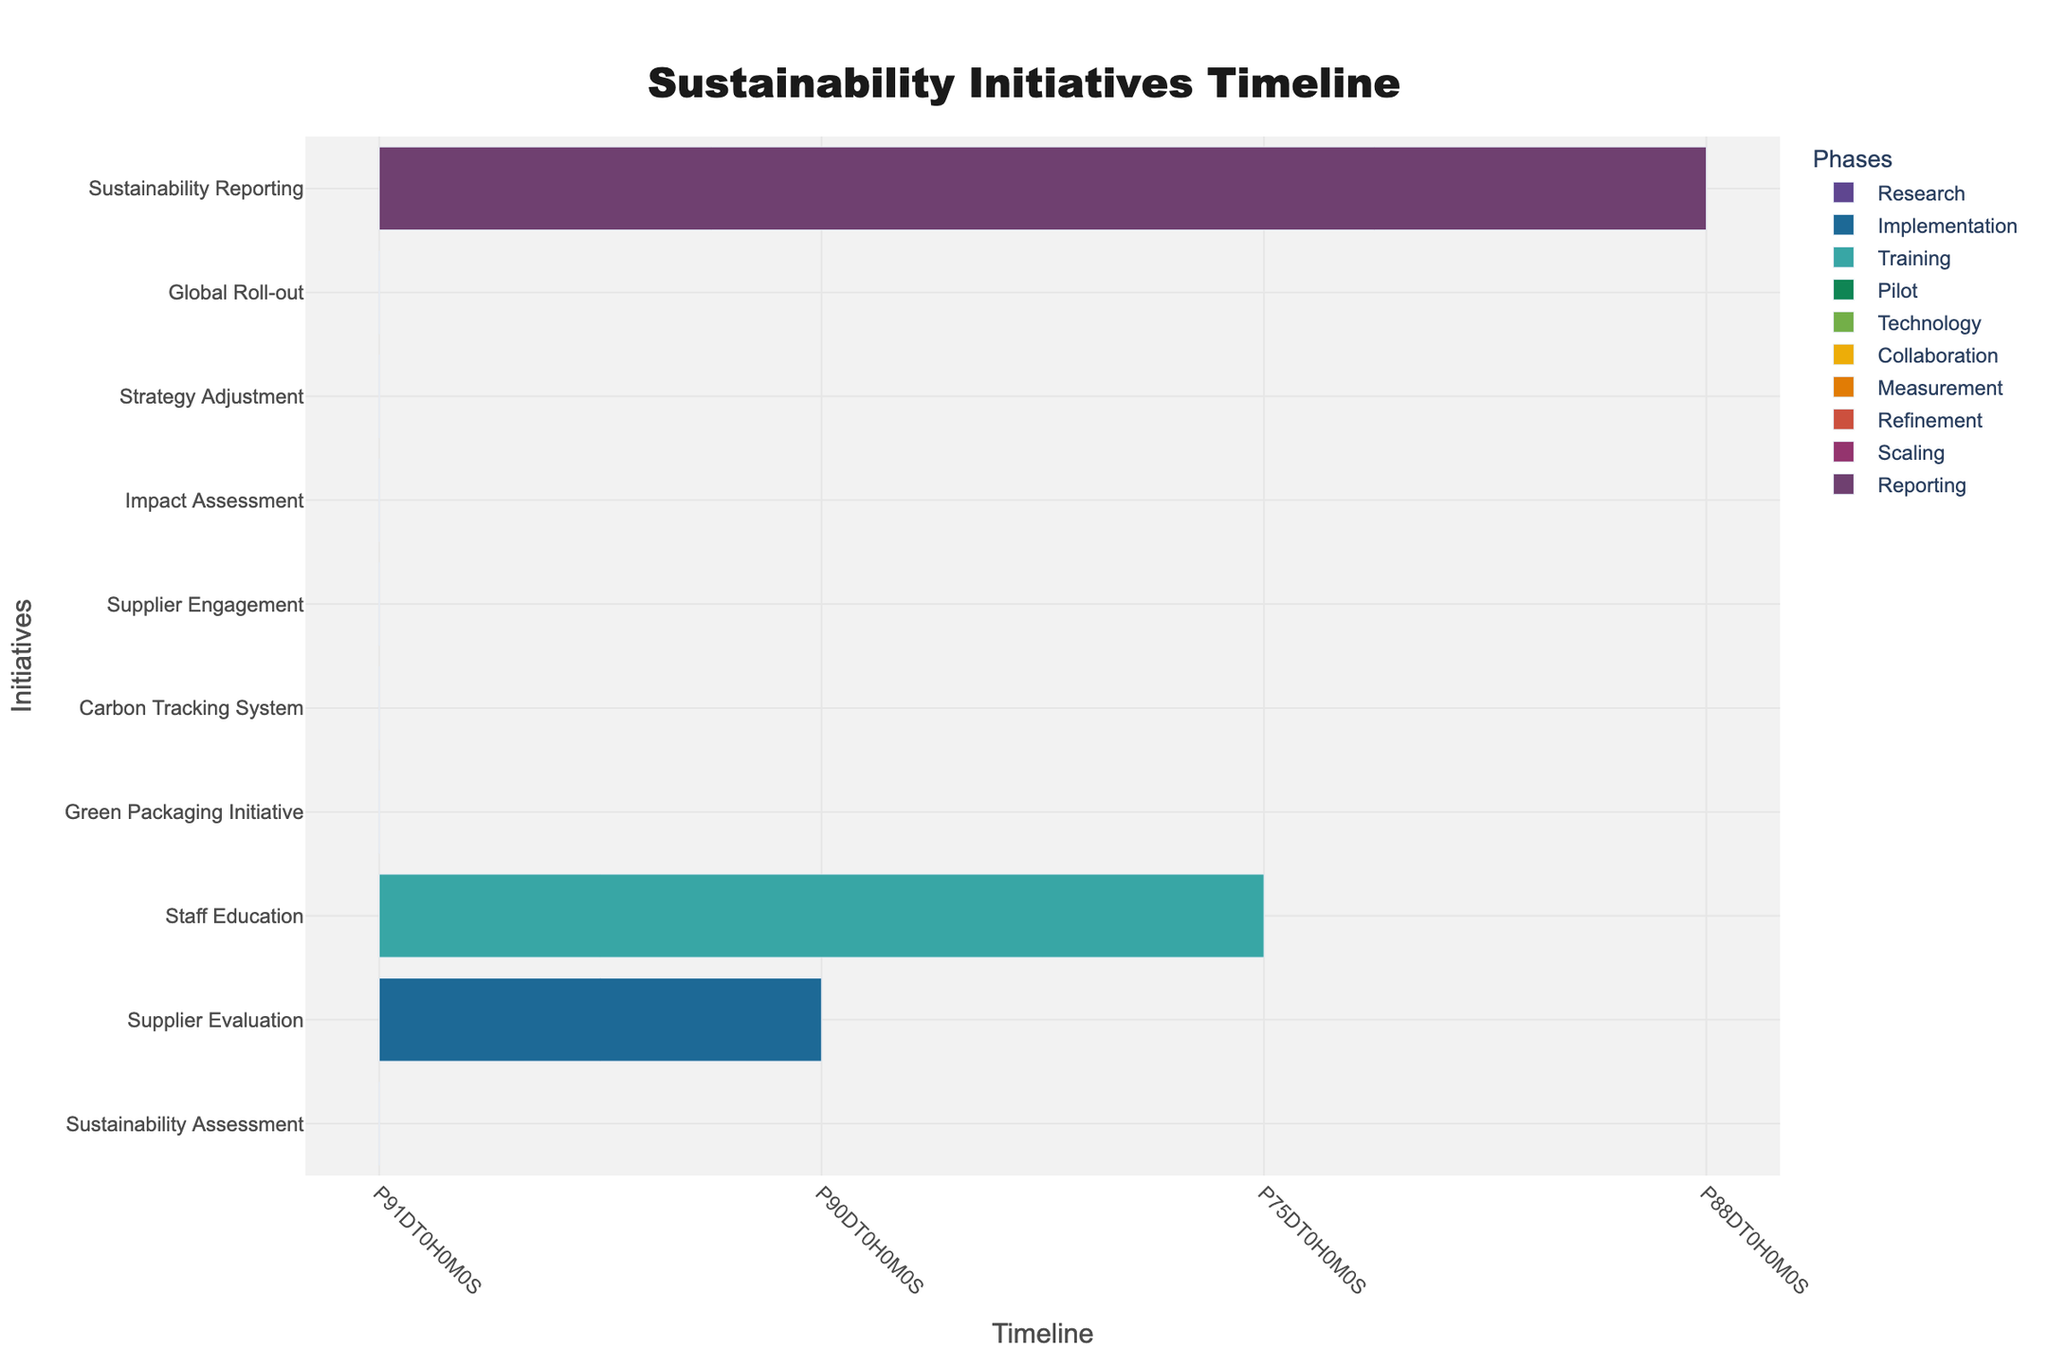What is the duration of the Sustainability Assessment phase? The Sustainability Assessment phase starts on July 1, 2023, and ends on September 30, 2023. The duration can be calculated by counting the days from the start date to the end date, which is 90 days.
Answer: 90 days How many initiatives are planned for implementation in 2024? The table outlines five initiatives with start dates in 2024: Supplier Evaluation, Staff Education, Green Packaging Initiative, Carbon Tracking System, and Supplier Engagement. Therefore, there are five initiatives planned for 2024.
Answer: Five Is there a training session scheduled to begin before the Supplier Evaluation initiative? The training session for Staff Education starts on February 15, 2024, while Supplier Evaluation begins on January 1, 2024. Since the training starts later than the Supplier Evaluation, the answer is no.
Answer: No What is the time gap between the end of the Carbon Tracking System initiative and the start of the Supplier Engagement initiative? The Carbon Tracking System ends on October 31, 2024, and Supplier Engagement starts on November 1, 2024. Therefore, the time gap between these two initiatives is one day.
Answer: One day Which initiative has the longest duration? To determine this, we calculate the duration for each initiative. The longest duration is found by examining these requests: 
- Sustainability Assessment: 90 days
- Supplier Evaluation: 90 days
- Staff Education: 75 days
- Green Packaging Initiative: 92 days
- Carbon Tracking System: 91 days
- Supplier Engagement: 92 days
- Impact Assessment: 61 days
- Strategy Adjustment: 61 days
- Global Roll-out: 61 days
- Sustainability Reporting: 88 days
The longest entries, Green Packaging Initiative and Supplier Engagement both have a duration of 92 days.
Answer: Green Packaging Initiative, Supplier Engagement When will the first comprehensive sustainability report be published? The table shows that the Sustainability Reporting initiative is scheduled to start on February 1, 2026, and will end on April 30, 2026. Thus, the first comprehensive sustainability report will be published during this time.
Answer: Between February 1 and April 30, 2026 What percentage of the initiatives have a start date in 2024? There are 10 initiatives listed, and 5 of them have start dates in 2024 (Supplier Evaluation, Staff Education, Green Packaging Initiative, Carbon Tracking System, Supplier Engagement). The percentage can be calculated as (5/10) * 100 = 50%.
Answer: 50% Is the Impact Assessment initiative scheduled to take place before the Refinement phase? The Impact Assessment initiative is scheduled to begin on May 1, 2025, while the Refinement phase starts on August 1, 2025. Since Impact Assessment starts before Refinement, the answer is yes.
Answer: Yes How many months are there between the end of the Global Roll-out initiative and when the Sustainability Reporting initiative starts? The Global Roll-out ends on January 31, 2026, and Sustainability Reporting starts on February 1, 2026. Therefore, the gap between these two dates is one day, which is a fraction of a month.
Answer: Less than one month 